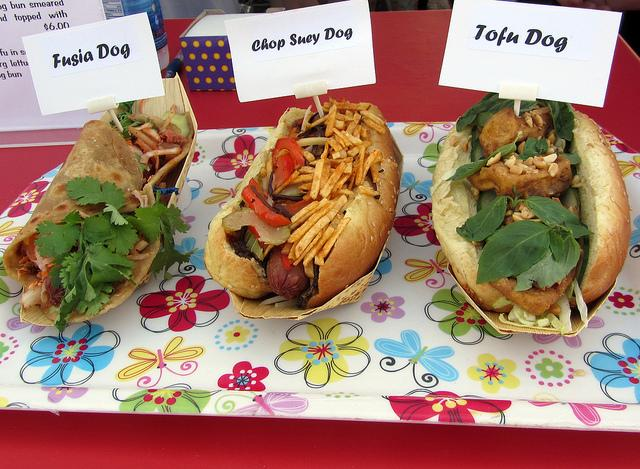What would a vegetarian order from this restaurant? tofu dog 